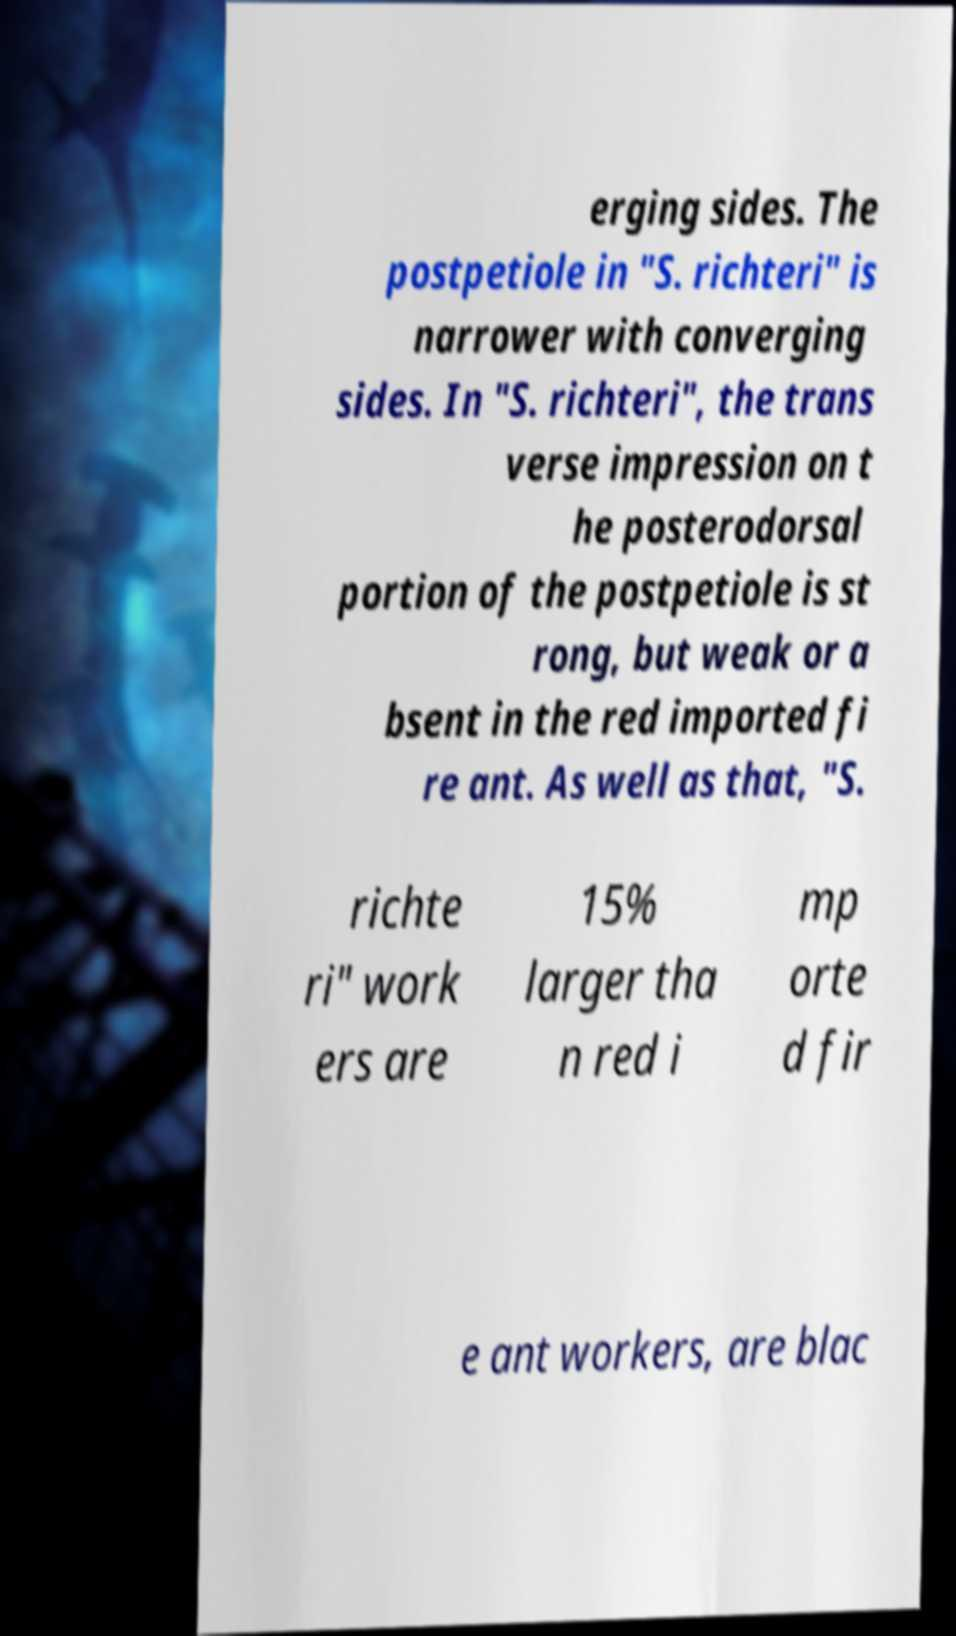Could you extract and type out the text from this image? erging sides. The postpetiole in "S. richteri" is narrower with converging sides. In "S. richteri", the trans verse impression on t he posterodorsal portion of the postpetiole is st rong, but weak or a bsent in the red imported fi re ant. As well as that, "S. richte ri" work ers are 15% larger tha n red i mp orte d fir e ant workers, are blac 